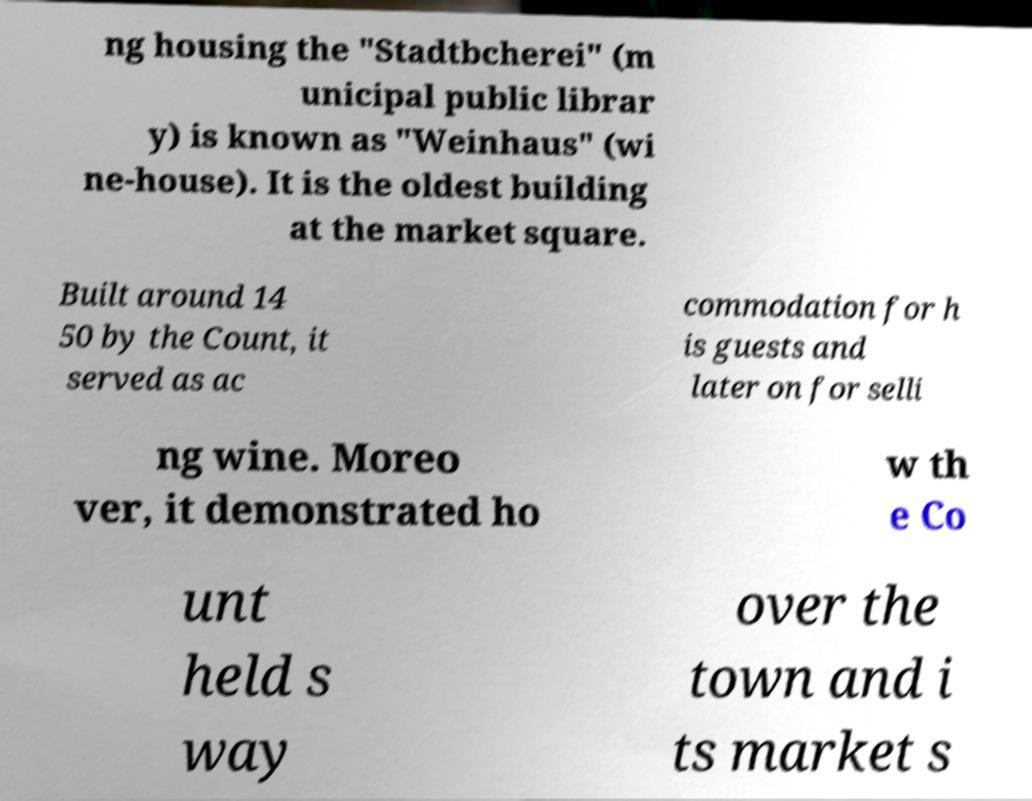Could you extract and type out the text from this image? ng housing the "Stadtbcherei" (m unicipal public librar y) is known as "Weinhaus" (wi ne-house). It is the oldest building at the market square. Built around 14 50 by the Count, it served as ac commodation for h is guests and later on for selli ng wine. Moreo ver, it demonstrated ho w th e Co unt held s way over the town and i ts market s 